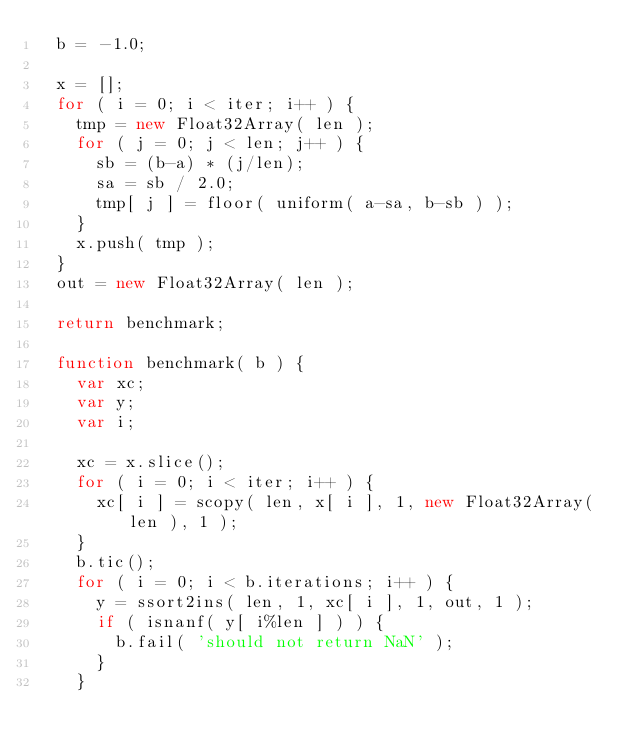<code> <loc_0><loc_0><loc_500><loc_500><_JavaScript_>	b = -1.0;

	x = [];
	for ( i = 0; i < iter; i++ ) {
		tmp = new Float32Array( len );
		for ( j = 0; j < len; j++ ) {
			sb = (b-a) * (j/len);
			sa = sb / 2.0;
			tmp[ j ] = floor( uniform( a-sa, b-sb ) );
		}
		x.push( tmp );
	}
	out = new Float32Array( len );

	return benchmark;

	function benchmark( b ) {
		var xc;
		var y;
		var i;

		xc = x.slice();
		for ( i = 0; i < iter; i++ ) {
			xc[ i ] = scopy( len, x[ i ], 1, new Float32Array( len ), 1 );
		}
		b.tic();
		for ( i = 0; i < b.iterations; i++ ) {
			y = ssort2ins( len, 1, xc[ i ], 1, out, 1 );
			if ( isnanf( y[ i%len ] ) ) {
				b.fail( 'should not return NaN' );
			}
		}</code> 